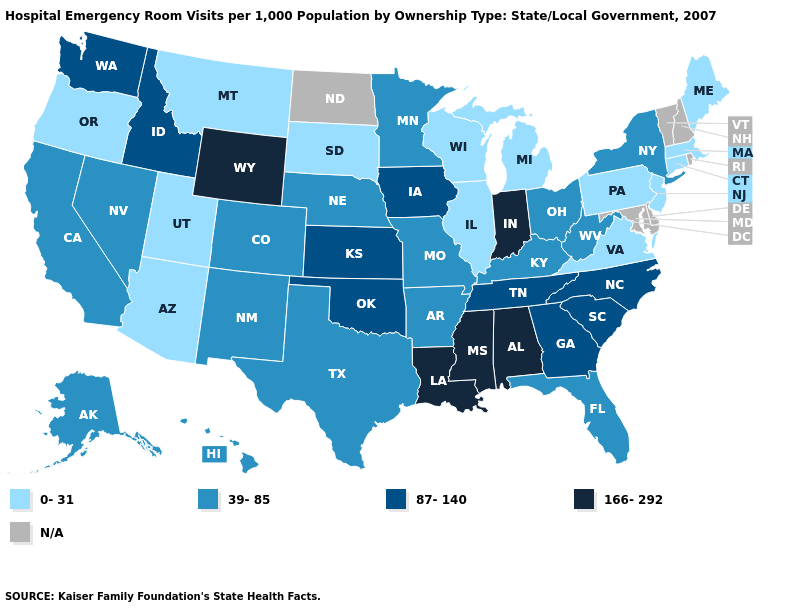Does Kentucky have the lowest value in the USA?
Be succinct. No. Which states have the lowest value in the Northeast?
Short answer required. Connecticut, Maine, Massachusetts, New Jersey, Pennsylvania. Name the states that have a value in the range 87-140?
Give a very brief answer. Georgia, Idaho, Iowa, Kansas, North Carolina, Oklahoma, South Carolina, Tennessee, Washington. What is the highest value in states that border New York?
Write a very short answer. 0-31. What is the lowest value in the USA?
Short answer required. 0-31. Name the states that have a value in the range 166-292?
Answer briefly. Alabama, Indiana, Louisiana, Mississippi, Wyoming. What is the value of North Dakota?
Write a very short answer. N/A. Does Louisiana have the highest value in the USA?
Concise answer only. Yes. Name the states that have a value in the range 166-292?
Concise answer only. Alabama, Indiana, Louisiana, Mississippi, Wyoming. Among the states that border West Virginia , does Ohio have the lowest value?
Quick response, please. No. What is the value of Iowa?
Quick response, please. 87-140. What is the value of Maryland?
Write a very short answer. N/A. Is the legend a continuous bar?
Give a very brief answer. No. Name the states that have a value in the range 166-292?
Answer briefly. Alabama, Indiana, Louisiana, Mississippi, Wyoming. 